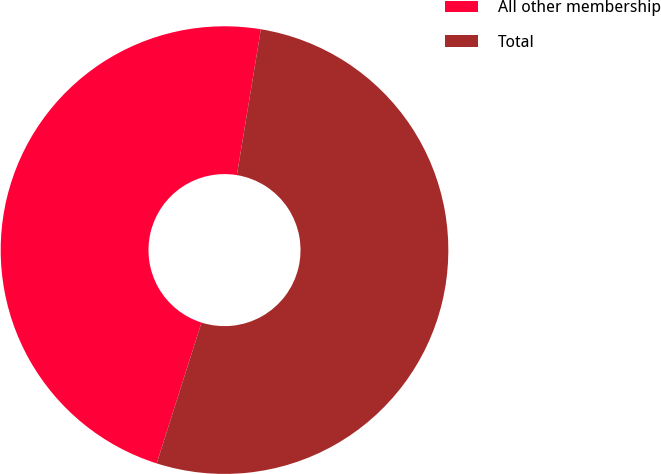<chart> <loc_0><loc_0><loc_500><loc_500><pie_chart><fcel>All other membership<fcel>Total<nl><fcel>47.7%<fcel>52.3%<nl></chart> 